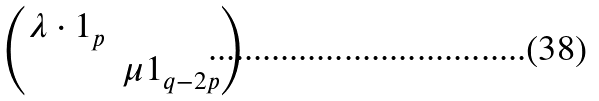Convert formula to latex. <formula><loc_0><loc_0><loc_500><loc_500>\begin{pmatrix} \lambda \cdot 1 _ { p } & \\ & \mu 1 _ { q - 2 p } \end{pmatrix}</formula> 